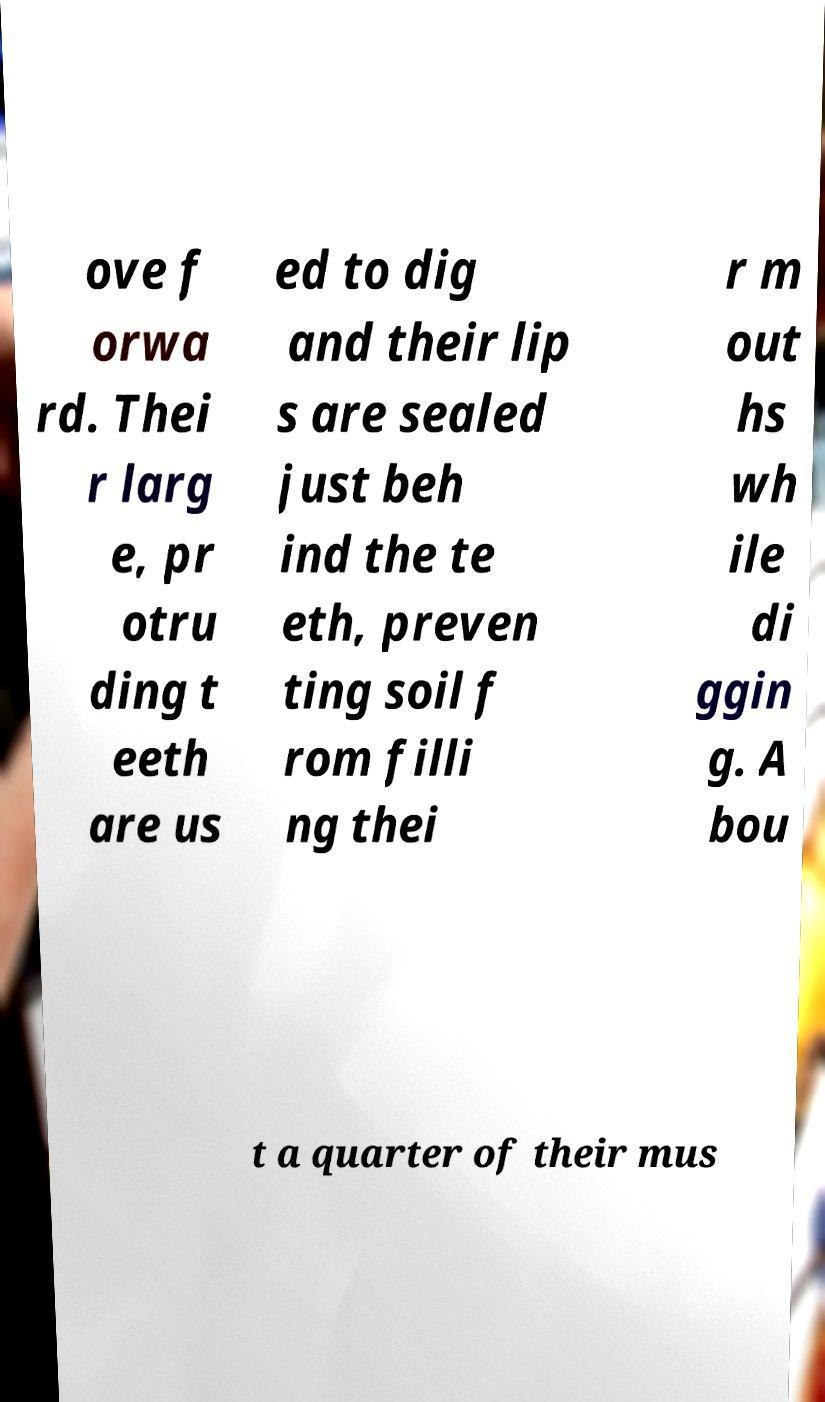Please identify and transcribe the text found in this image. ove f orwa rd. Thei r larg e, pr otru ding t eeth are us ed to dig and their lip s are sealed just beh ind the te eth, preven ting soil f rom filli ng thei r m out hs wh ile di ggin g. A bou t a quarter of their mus 